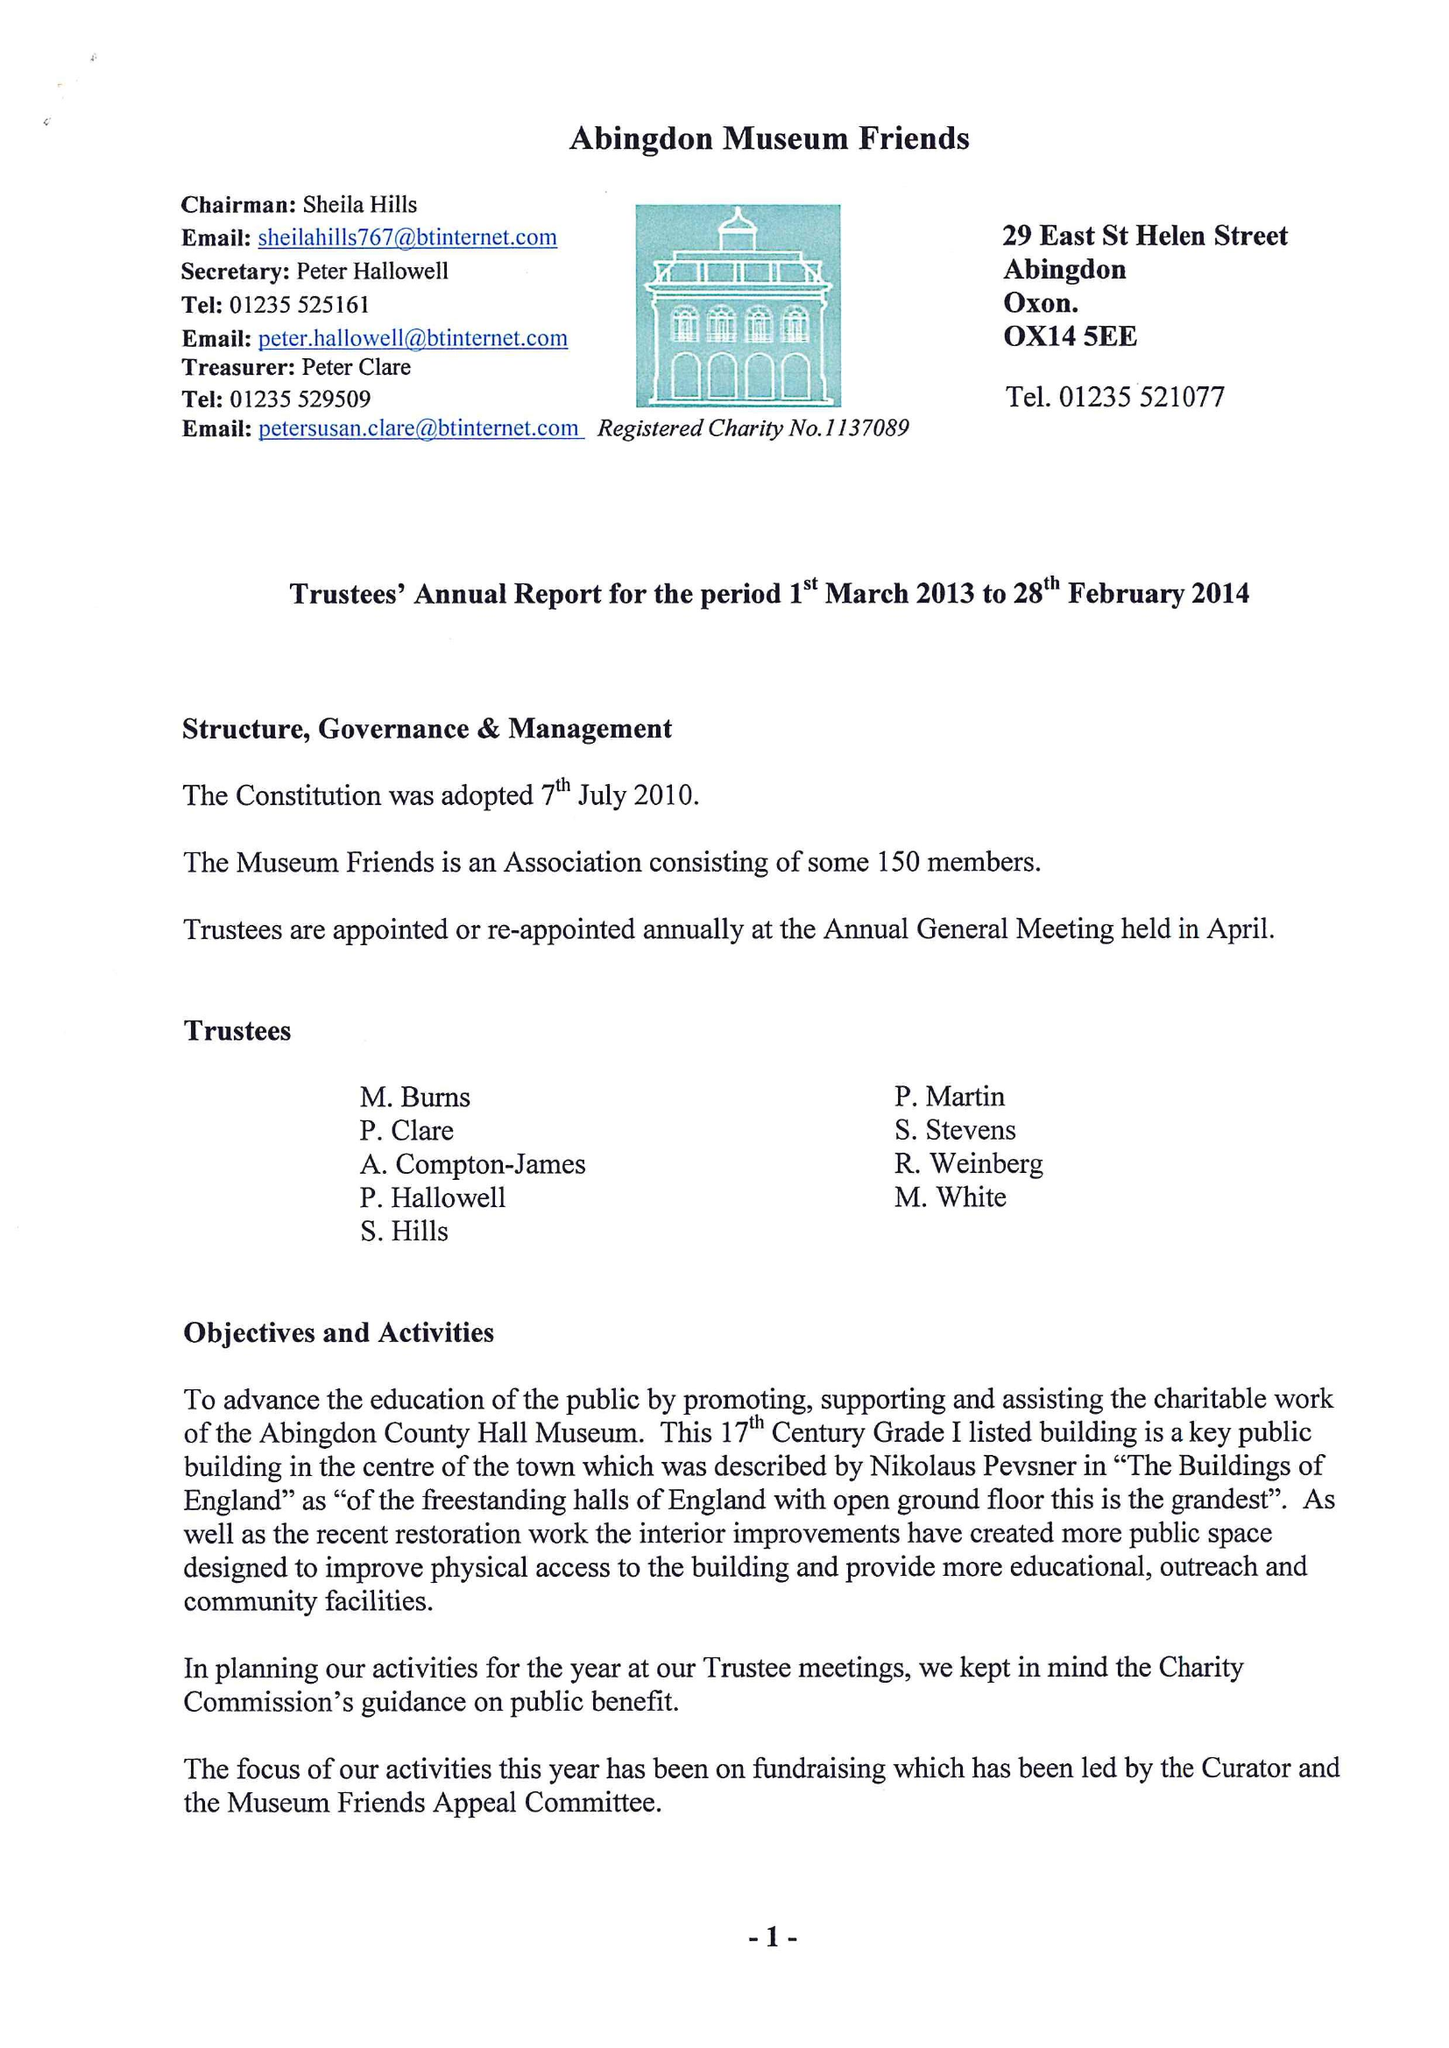What is the value for the address__post_town?
Answer the question using a single word or phrase. ABINGDON 